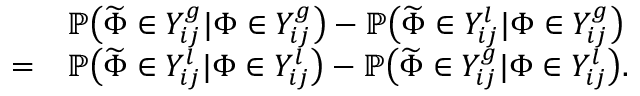<formula> <loc_0><loc_0><loc_500><loc_500>\begin{array} { r l } & { \mathbb { P } \left ( \widetilde { \Phi } \in Y _ { i j } ^ { g } | \Phi \in Y _ { i j } ^ { g } \right ) - \mathbb { P } \left ( \widetilde { \Phi } \in Y _ { i j } ^ { l } | \Phi \in Y _ { i j } ^ { g } \right ) } \\ { = } & { \mathbb { P } \left ( \widetilde { \Phi } \in Y _ { i j } ^ { l } | \Phi \in Y _ { i j } ^ { l } \right ) - \mathbb { P } \left ( \widetilde { \Phi } \in Y _ { i j } ^ { g } | \Phi \in Y _ { i j } ^ { l } \right ) . } \end{array}</formula> 